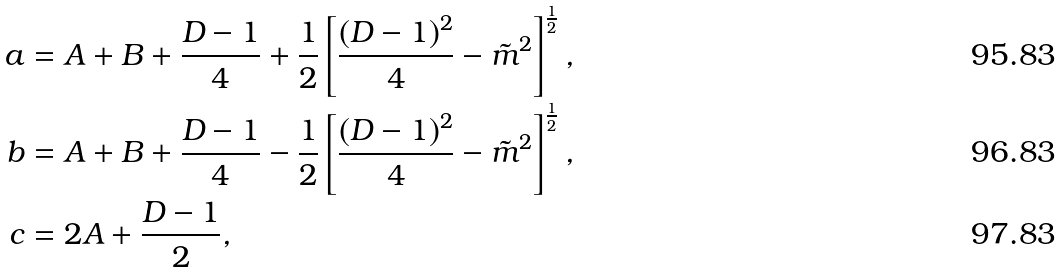<formula> <loc_0><loc_0><loc_500><loc_500>a & = A + B + \frac { D - 1 } { 4 } + \frac { 1 } { 2 } \left [ \frac { ( D - 1 ) ^ { 2 } } { 4 } - \tilde { m } ^ { 2 } \right ] ^ { \frac { 1 } { 2 } } , \\ b & = A + B + \frac { D - 1 } { 4 } - \frac { 1 } { 2 } \left [ \frac { ( D - 1 ) ^ { 2 } } { 4 } - \tilde { m } ^ { 2 } \right ] ^ { \frac { 1 } { 2 } } , \\ c & = 2 A + \frac { D - 1 } { 2 } ,</formula> 